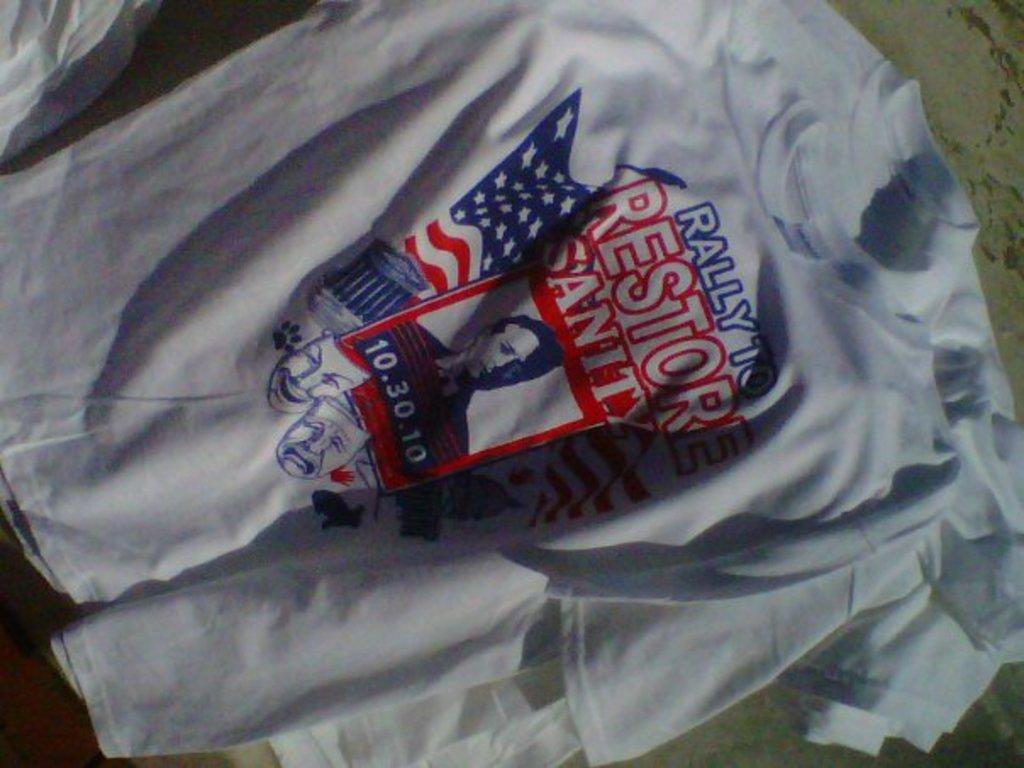Provide a one-sentence caption for the provided image. A red white and blue themed Rally to Restore Sanity T-shirt. 